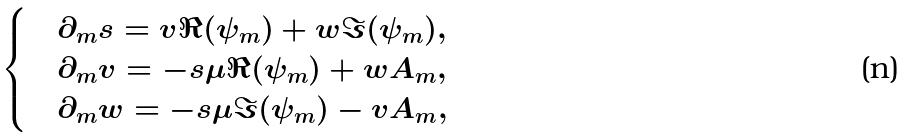<formula> <loc_0><loc_0><loc_500><loc_500>\begin{cases} & \partial _ { m } s = v \Re ( \psi _ { m } ) + w \Im ( \psi _ { m } ) , \\ & \partial _ { m } v = - s \mu \Re ( \psi _ { m } ) + w A _ { m } , \\ & \partial _ { m } w = - s \mu \Im ( \psi _ { m } ) - v A _ { m } , \end{cases}</formula> 